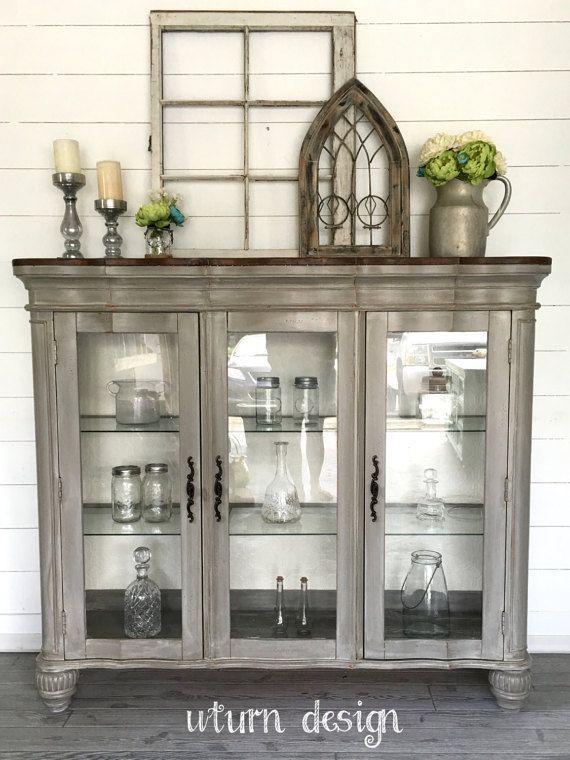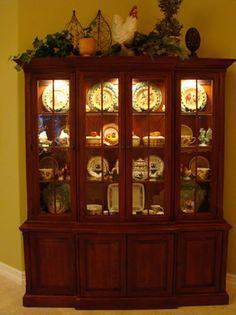The first image is the image on the left, the second image is the image on the right. For the images displayed, is the sentence "One of the cabinets is dark wood with four glass doors and a non-flat top." factually correct? Answer yes or no. No. The first image is the image on the left, the second image is the image on the right. Assess this claim about the two images: "There is a floor plant near a hutch in one of the images.". Correct or not? Answer yes or no. No. The first image is the image on the left, the second image is the image on the right. Evaluate the accuracy of this statement regarding the images: "One of the wooden cabinets is not flat across the top.". Is it true? Answer yes or no. No. The first image is the image on the left, the second image is the image on the right. Examine the images to the left and right. Is the description "There is one picture frame in the image on the right." accurate? Answer yes or no. No. 